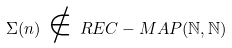<formula> <loc_0><loc_0><loc_500><loc_500>\Sigma ( n ) \, \notin \, R E C - M A P ( { \mathbb { N } } , { \mathbb { N } } )</formula> 